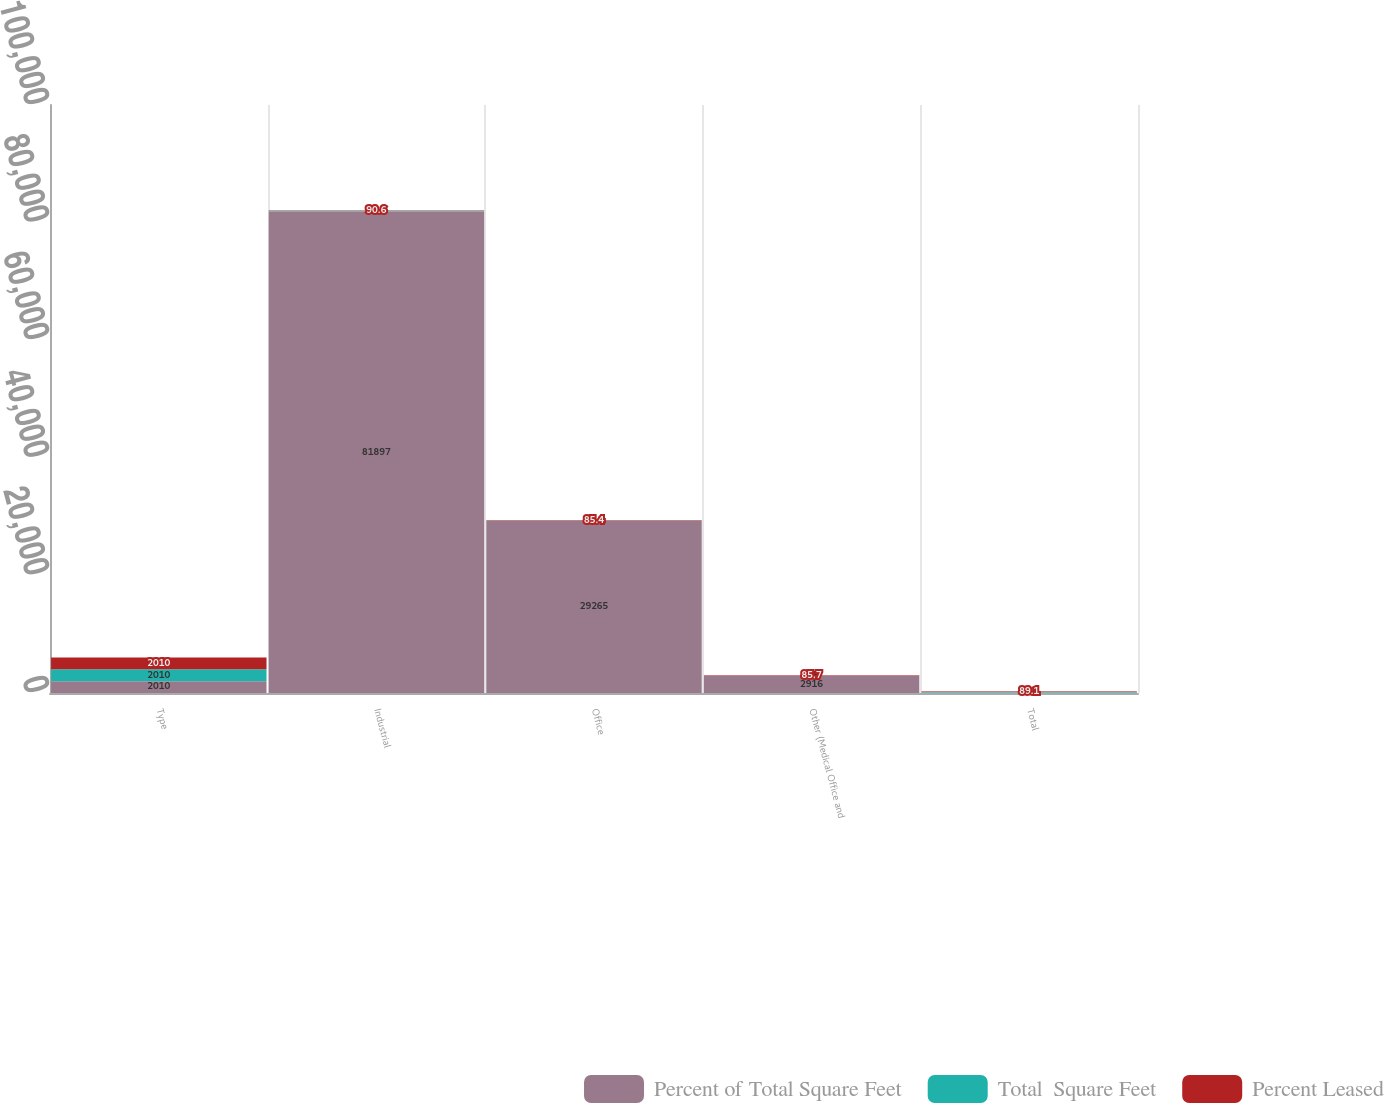Convert chart. <chart><loc_0><loc_0><loc_500><loc_500><stacked_bar_chart><ecel><fcel>Type<fcel>Industrial<fcel>Office<fcel>Other (Medical Office and<fcel>Total<nl><fcel>Percent of Total Square Feet<fcel>2010<fcel>81897<fcel>29265<fcel>2916<fcel>95.3<nl><fcel>Total  Square Feet<fcel>2010<fcel>71.8<fcel>25.7<fcel>2.5<fcel>100<nl><fcel>Percent Leased<fcel>2010<fcel>90.6<fcel>85.4<fcel>85.7<fcel>89.1<nl></chart> 